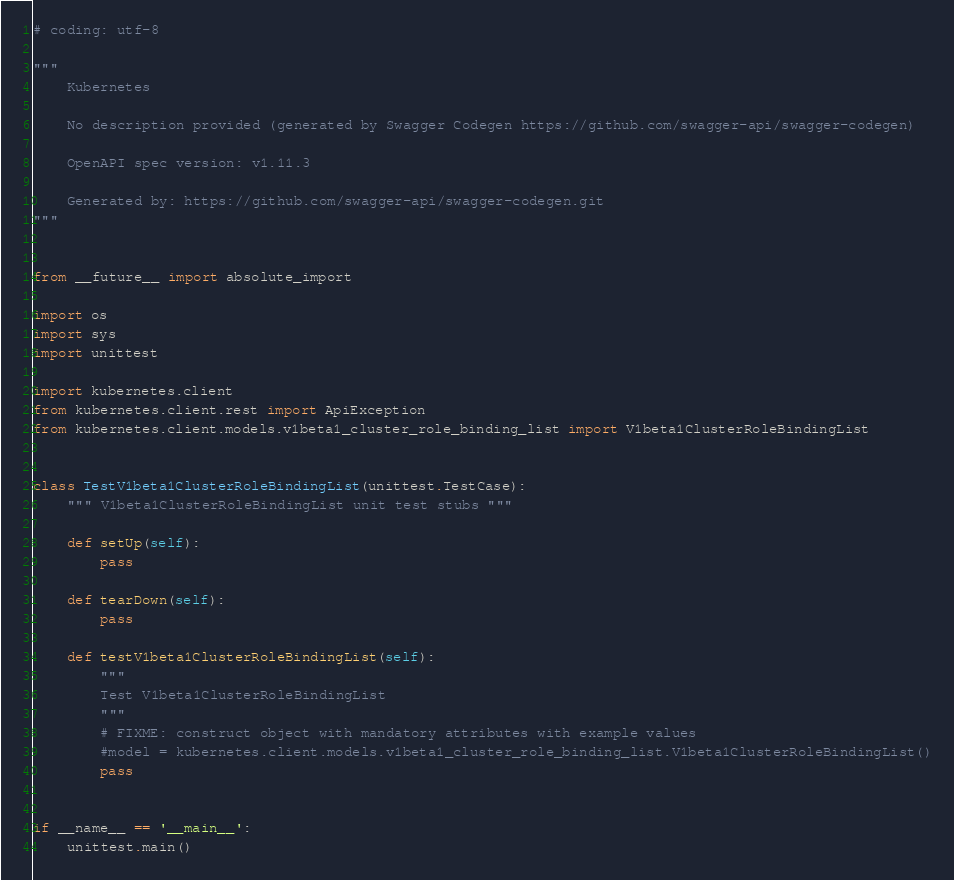Convert code to text. <code><loc_0><loc_0><loc_500><loc_500><_Python_># coding: utf-8

"""
    Kubernetes

    No description provided (generated by Swagger Codegen https://github.com/swagger-api/swagger-codegen)

    OpenAPI spec version: v1.11.3
    
    Generated by: https://github.com/swagger-api/swagger-codegen.git
"""


from __future__ import absolute_import

import os
import sys
import unittest

import kubernetes.client
from kubernetes.client.rest import ApiException
from kubernetes.client.models.v1beta1_cluster_role_binding_list import V1beta1ClusterRoleBindingList


class TestV1beta1ClusterRoleBindingList(unittest.TestCase):
    """ V1beta1ClusterRoleBindingList unit test stubs """

    def setUp(self):
        pass

    def tearDown(self):
        pass

    def testV1beta1ClusterRoleBindingList(self):
        """
        Test V1beta1ClusterRoleBindingList
        """
        # FIXME: construct object with mandatory attributes with example values
        #model = kubernetes.client.models.v1beta1_cluster_role_binding_list.V1beta1ClusterRoleBindingList()
        pass


if __name__ == '__main__':
    unittest.main()
</code> 